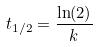<formula> <loc_0><loc_0><loc_500><loc_500>t _ { 1 / 2 } = \frac { \ln ( 2 ) } { k }</formula> 